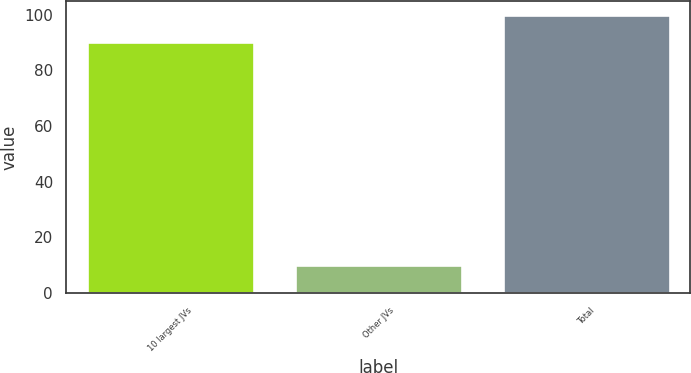<chart> <loc_0><loc_0><loc_500><loc_500><bar_chart><fcel>10 largest JVs<fcel>Other JVs<fcel>Total<nl><fcel>90<fcel>10<fcel>100<nl></chart> 